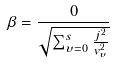<formula> <loc_0><loc_0><loc_500><loc_500>\beta = \frac { 0 } { \sqrt { \sum _ { \upsilon = 0 } ^ { s } \frac { j ^ { 2 } } { v _ { \upsilon } ^ { 2 } } } }</formula> 